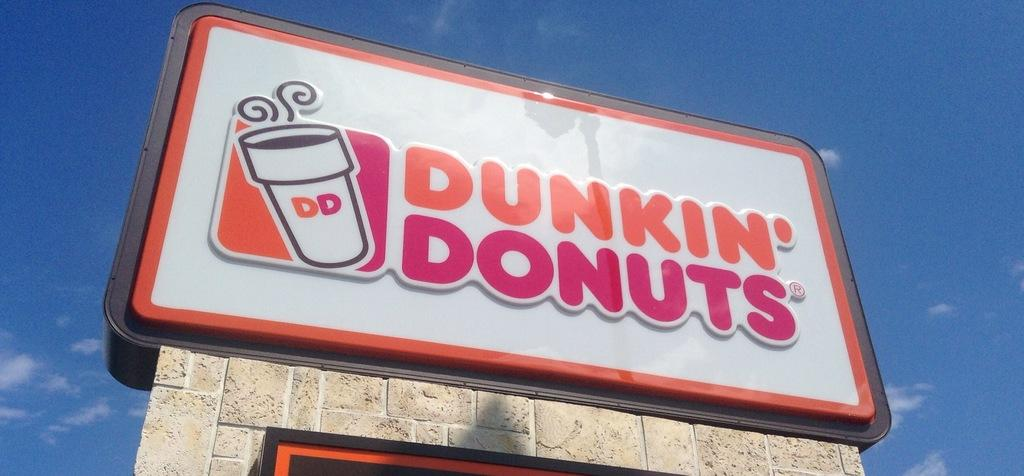<image>
Relay a brief, clear account of the picture shown. Dunkin' Donuts large sign outside their store location. 